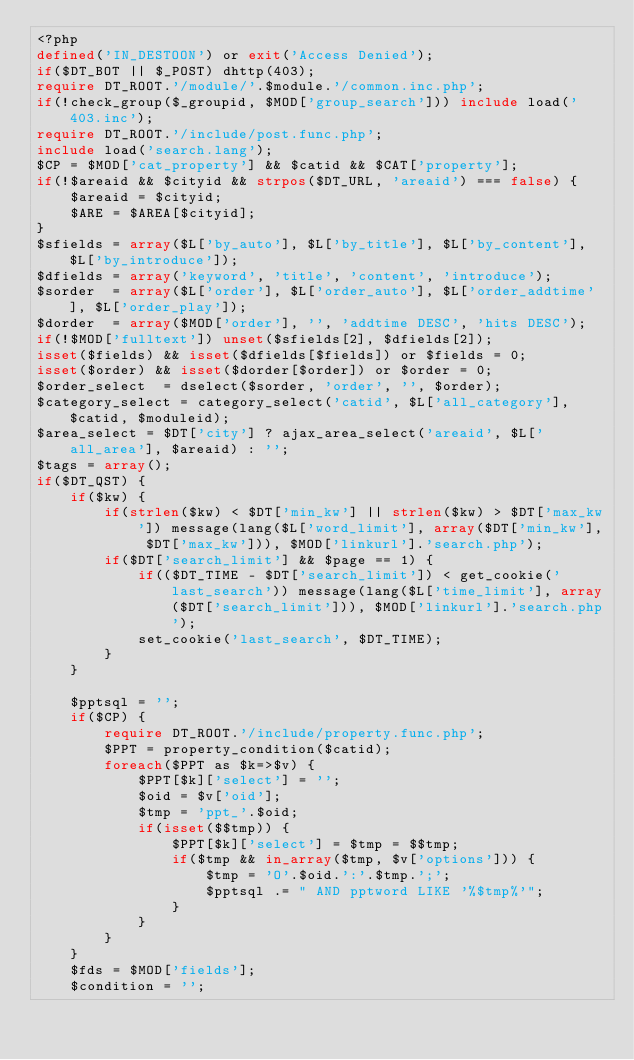<code> <loc_0><loc_0><loc_500><loc_500><_PHP_><?php 
defined('IN_DESTOON') or exit('Access Denied');
if($DT_BOT || $_POST) dhttp(403);
require DT_ROOT.'/module/'.$module.'/common.inc.php';
if(!check_group($_groupid, $MOD['group_search'])) include load('403.inc');
require DT_ROOT.'/include/post.func.php';
include load('search.lang');
$CP = $MOD['cat_property'] && $catid && $CAT['property'];
if(!$areaid && $cityid && strpos($DT_URL, 'areaid') === false) {
	$areaid = $cityid;
	$ARE = $AREA[$cityid];
}
$sfields = array($L['by_auto'], $L['by_title'], $L['by_content'], $L['by_introduce']);
$dfields = array('keyword', 'title', 'content', 'introduce');
$sorder  = array($L['order'], $L['order_auto'], $L['order_addtime'], $L['order_play']);
$dorder  = array($MOD['order'], '', 'addtime DESC', 'hits DESC');
if(!$MOD['fulltext']) unset($sfields[2], $dfields[2]);
isset($fields) && isset($dfields[$fields]) or $fields = 0;
isset($order) && isset($dorder[$order]) or $order = 0;
$order_select  = dselect($sorder, 'order', '', $order);
$category_select = category_select('catid', $L['all_category'], $catid, $moduleid);
$area_select = $DT['city'] ? ajax_area_select('areaid', $L['all_area'], $areaid) : '';
$tags = array();
if($DT_QST) {
	if($kw) {
		if(strlen($kw) < $DT['min_kw'] || strlen($kw) > $DT['max_kw']) message(lang($L['word_limit'], array($DT['min_kw'], $DT['max_kw'])), $MOD['linkurl'].'search.php');
		if($DT['search_limit'] && $page == 1) {
			if(($DT_TIME - $DT['search_limit']) < get_cookie('last_search')) message(lang($L['time_limit'], array($DT['search_limit'])), $MOD['linkurl'].'search.php');
			set_cookie('last_search', $DT_TIME);
		}
	}

	$pptsql = '';
	if($CP) {
		require DT_ROOT.'/include/property.func.php';
		$PPT = property_condition($catid);
		foreach($PPT as $k=>$v) {
			$PPT[$k]['select'] = '';
			$oid = $v['oid'];
			$tmp = 'ppt_'.$oid;
			if(isset($$tmp)) {
				$PPT[$k]['select'] = $tmp = $$tmp;
				if($tmp && in_array($tmp, $v['options'])) {
					$tmp = 'O'.$oid.':'.$tmp.';';
					$pptsql .= " AND pptword LIKE '%$tmp%'";
				}
			}
		}
	}
	$fds = $MOD['fields'];
	$condition = '';</code> 